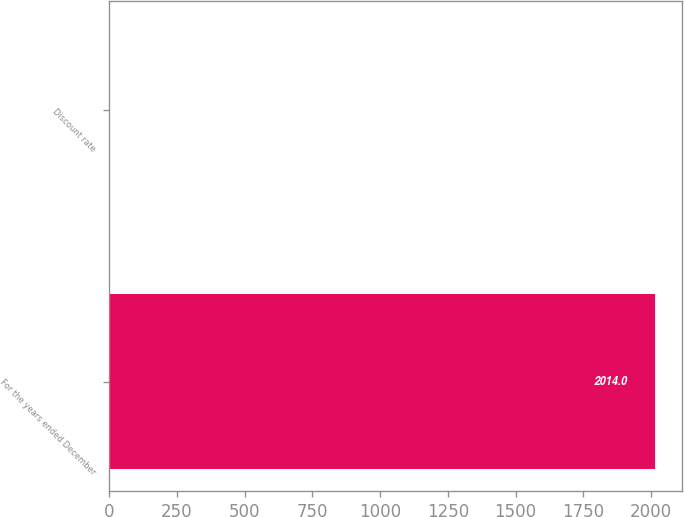Convert chart to OTSL. <chart><loc_0><loc_0><loc_500><loc_500><bar_chart><fcel>For the years ended December<fcel>Discount rate<nl><fcel>2014<fcel>4.5<nl></chart> 